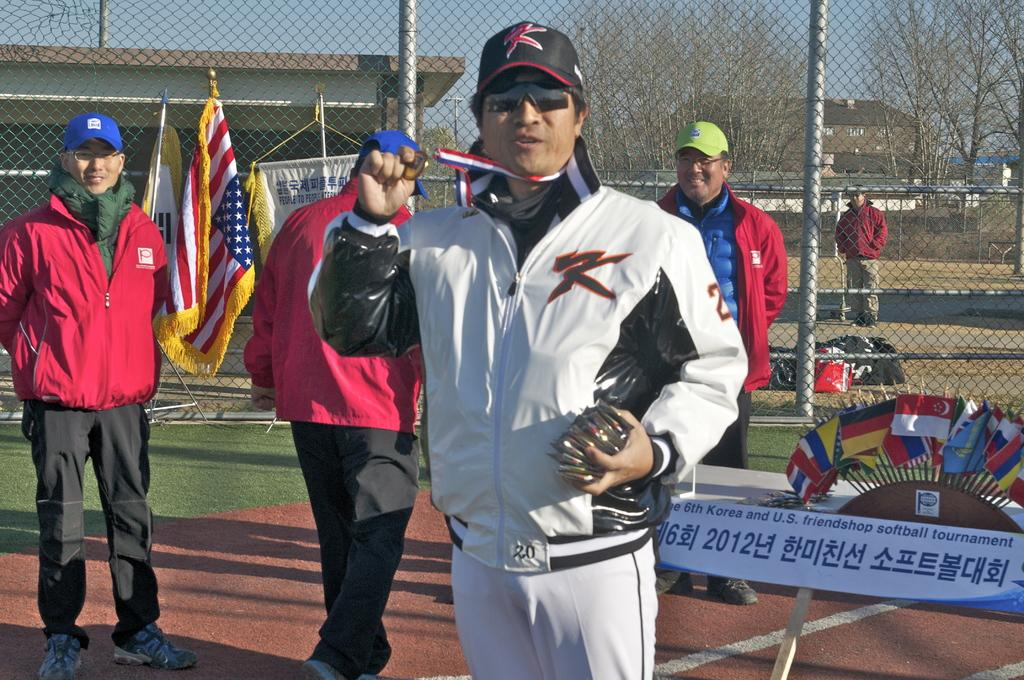<image>
Summarize the visual content of the image. A man shows off his medal at the 6th Korean and U.S friendshop softball tournament. 